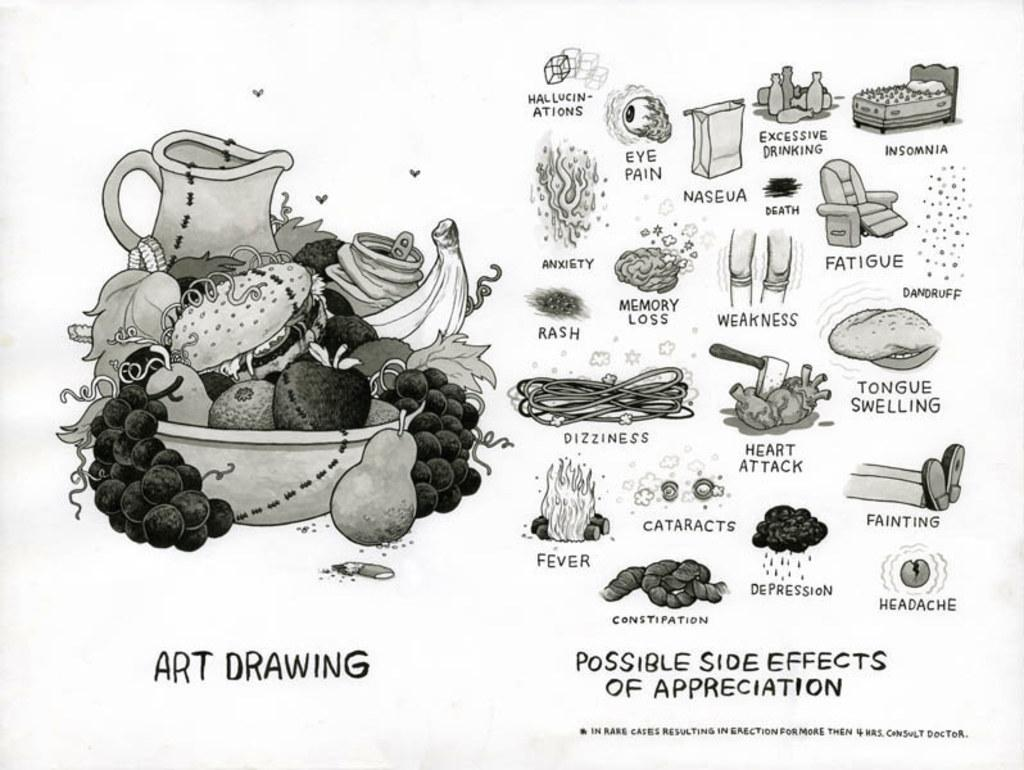What type of image is depicted in the picture? There is a cartoon image of fruits in the picture. What type of furniture is present in the picture? There is a chair in the picture. What other piece of furniture is present in the picture? There is a bed in the picture. What objects are present in the picture besides the furniture? There are bottles in the picture. What is the color scheme of the picture? The picture is black and white in color. How many houses are visible in the picture? There are no houses visible in the picture; it features a cartoon image of fruits, furniture, and bottles. What type of arch can be seen in the picture? There is no arch present in the picture. 